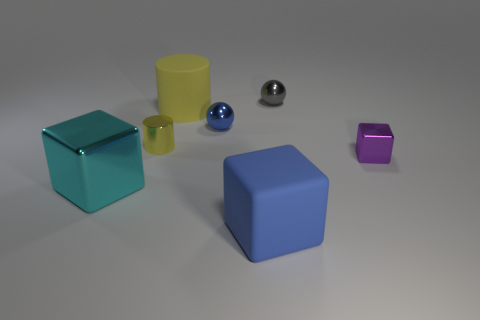There is a metal block to the right of the large blue block; does it have the same color as the small ball that is behind the large yellow matte cylinder?
Make the answer very short. No. What size is the cylinder that is on the right side of the small cylinder that is to the left of the tiny metal sphere left of the small gray metallic sphere?
Keep it short and to the point. Large. The large thing that is in front of the small yellow shiny thing and behind the big rubber cube has what shape?
Ensure brevity in your answer.  Cube. Are there the same number of large matte blocks behind the large yellow matte cylinder and tiny cylinders behind the tiny gray metallic thing?
Make the answer very short. Yes. Are there any cyan cubes that have the same material as the blue ball?
Give a very brief answer. Yes. Does the large object on the right side of the big yellow rubber thing have the same material as the cyan cube?
Make the answer very short. No. There is a metallic thing that is both on the left side of the yellow rubber cylinder and behind the large metallic block; what size is it?
Ensure brevity in your answer.  Small. What is the color of the rubber cylinder?
Offer a terse response. Yellow. What number of big yellow metallic things are there?
Your answer should be compact. 0. How many metallic objects have the same color as the matte block?
Your answer should be very brief. 1. 